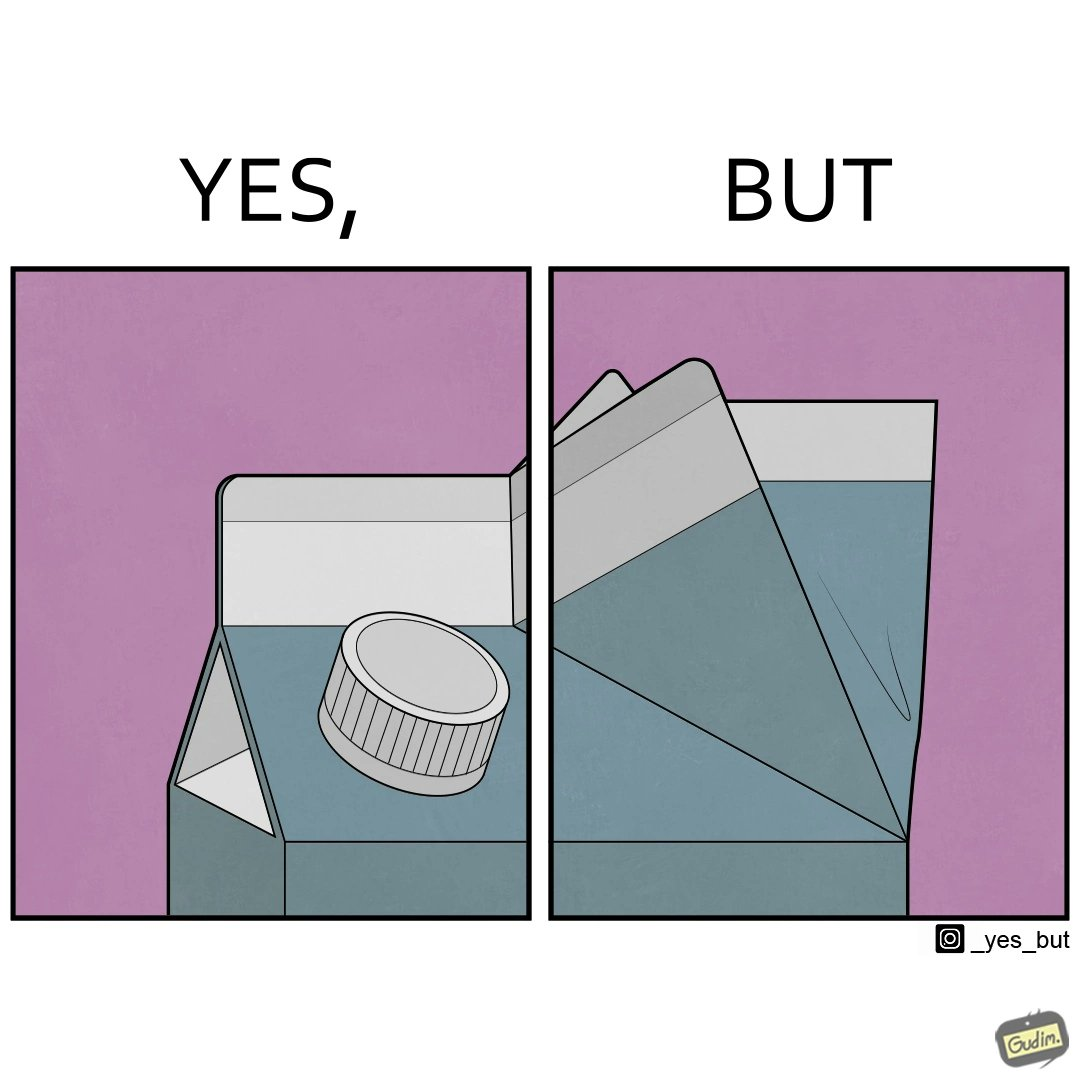What makes this image funny or satirical? The image is ironic, because on the one side tetra packs have cap or lid for opening but on the other side the folded end seems inconvenient to handle 